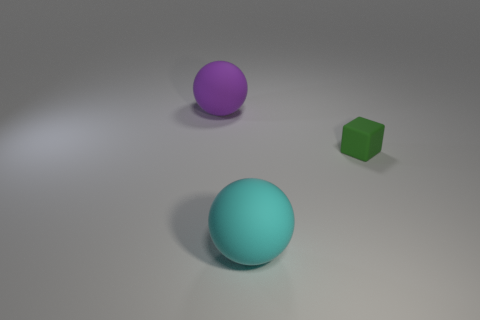Add 2 big cyan rubber spheres. How many objects exist? 5 Subtract all balls. How many objects are left? 1 Subtract all large matte things. Subtract all large purple shiny cubes. How many objects are left? 1 Add 3 green matte cubes. How many green matte cubes are left? 4 Add 1 big purple balls. How many big purple balls exist? 2 Subtract 0 red cylinders. How many objects are left? 3 